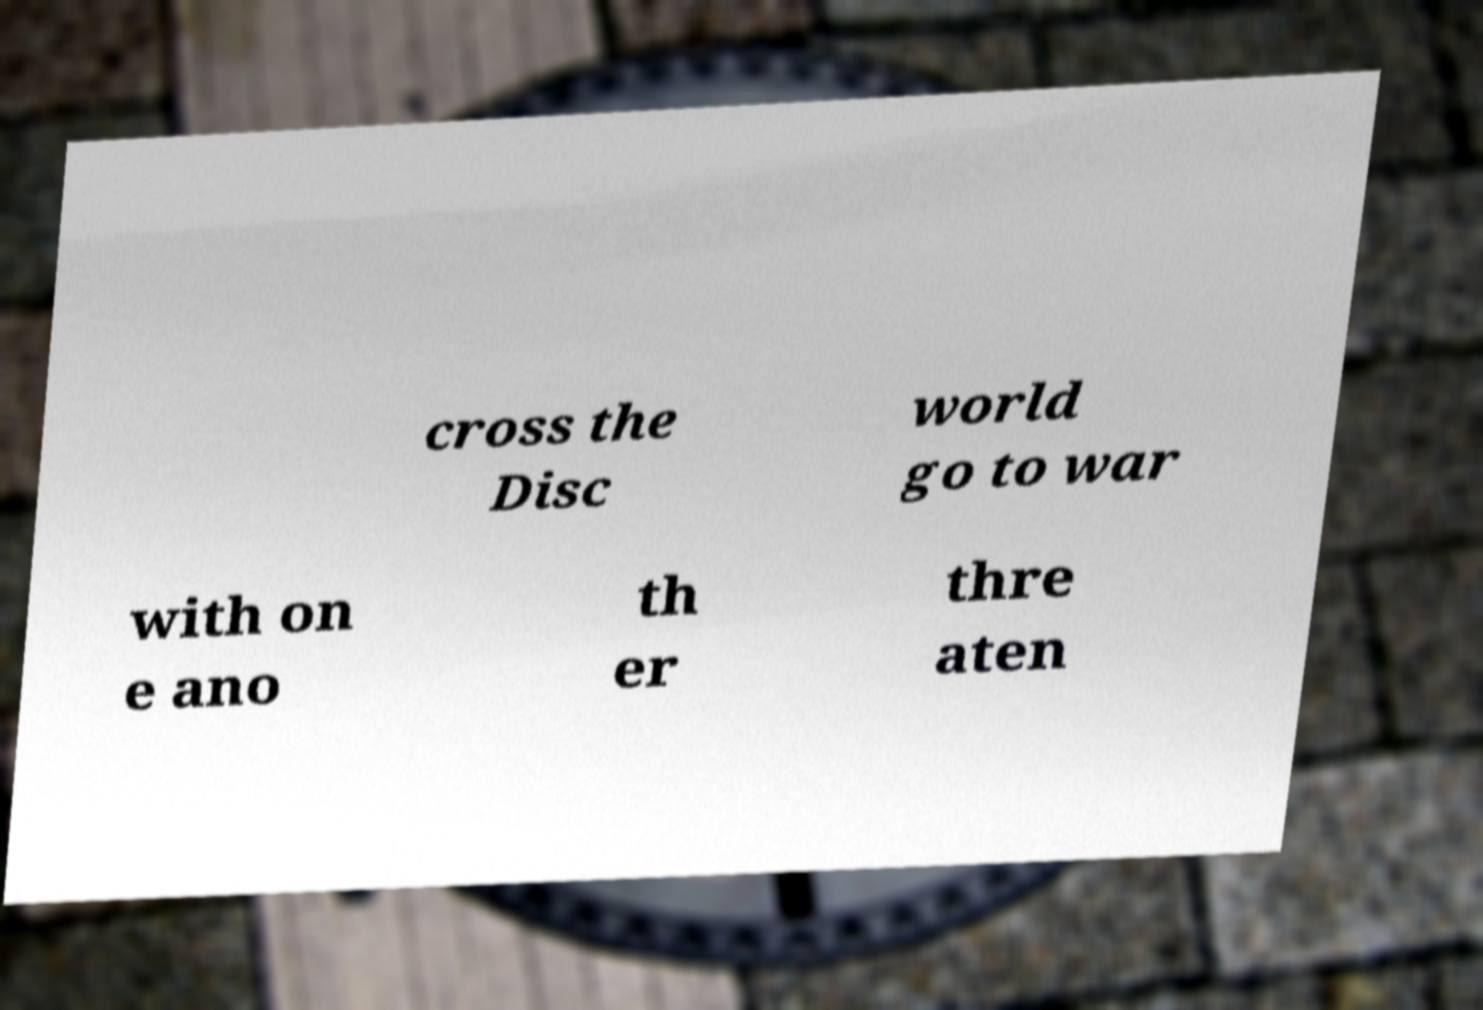There's text embedded in this image that I need extracted. Can you transcribe it verbatim? cross the Disc world go to war with on e ano th er thre aten 